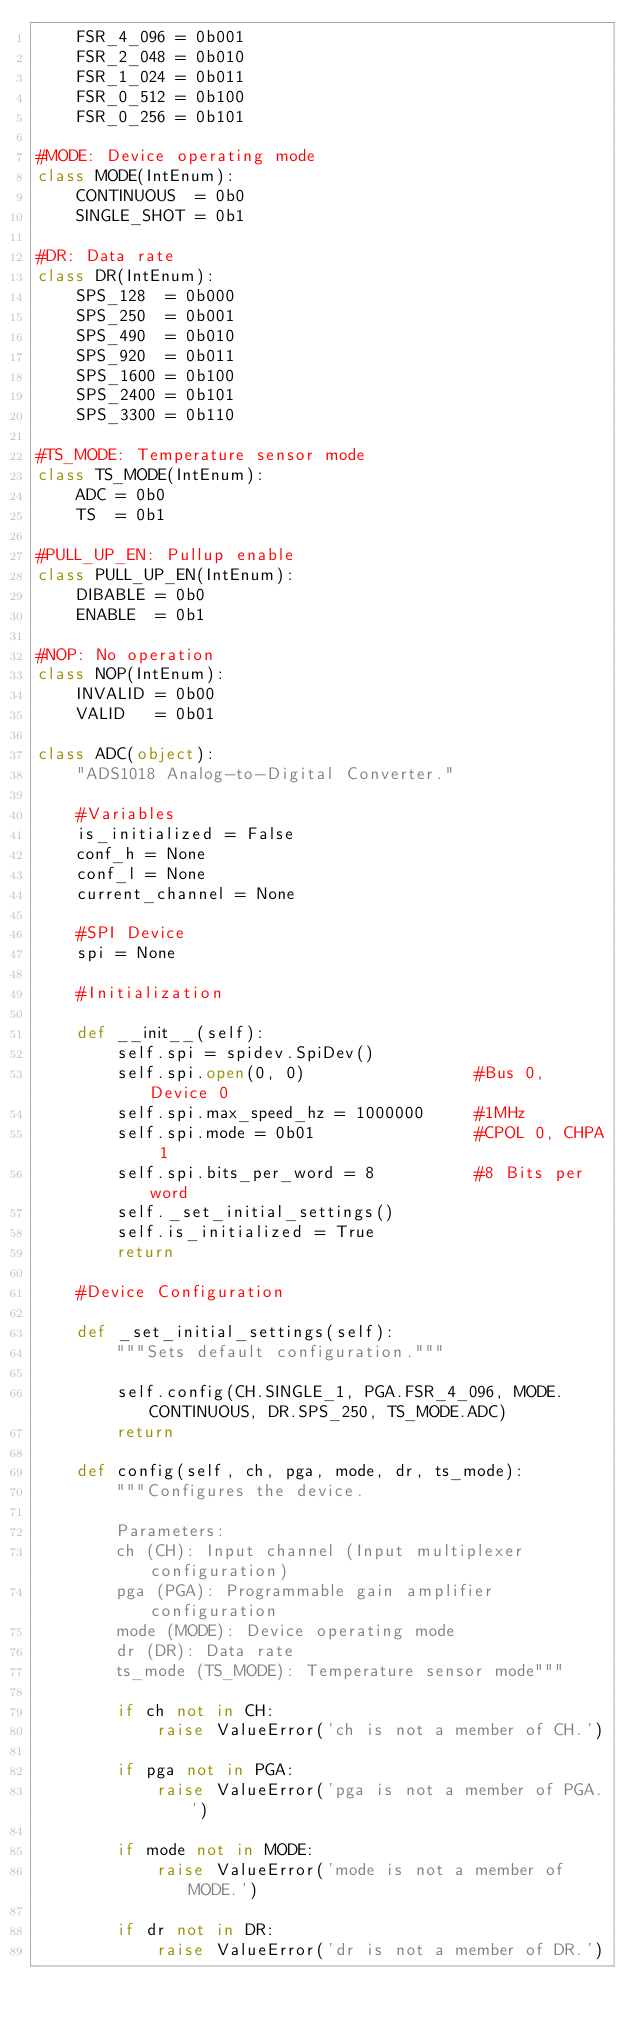<code> <loc_0><loc_0><loc_500><loc_500><_Python_>    FSR_4_096 = 0b001
    FSR_2_048 = 0b010
    FSR_1_024 = 0b011
    FSR_0_512 = 0b100
    FSR_0_256 = 0b101

#MODE: Device operating mode
class MODE(IntEnum):
    CONTINUOUS  = 0b0
    SINGLE_SHOT = 0b1

#DR: Data rate
class DR(IntEnum):
    SPS_128  = 0b000
    SPS_250  = 0b001
    SPS_490  = 0b010
    SPS_920  = 0b011
    SPS_1600 = 0b100
    SPS_2400 = 0b101
    SPS_3300 = 0b110

#TS_MODE: Temperature sensor mode
class TS_MODE(IntEnum):
    ADC = 0b0
    TS  = 0b1

#PULL_UP_EN: Pullup enable
class PULL_UP_EN(IntEnum):
    DIBABLE = 0b0
    ENABLE  = 0b1

#NOP: No operation
class NOP(IntEnum):
    INVALID = 0b00
    VALID   = 0b01

class ADC(object):
    "ADS1018 Analog-to-Digital Converter."

    #Variables
    is_initialized = False
    conf_h = None
    conf_l = None
    current_channel = None

    #SPI Device
    spi = None

    #Initialization

    def __init__(self):
        self.spi = spidev.SpiDev()
        self.spi.open(0, 0)                 #Bus 0, Device 0
        self.spi.max_speed_hz = 1000000     #1MHz
        self.spi.mode = 0b01                #CPOL 0, CHPA 1
        self.spi.bits_per_word = 8          #8 Bits per word
        self._set_initial_settings()
        self.is_initialized = True
        return

    #Device Configuration

    def _set_initial_settings(self):
        """Sets default configuration."""

        self.config(CH.SINGLE_1, PGA.FSR_4_096, MODE.CONTINUOUS, DR.SPS_250, TS_MODE.ADC)
        return

    def config(self, ch, pga, mode, dr, ts_mode):
        """Configures the device.

        Parameters:
        ch (CH): Input channel (Input multiplexer configuration)
        pga (PGA): Programmable gain amplifier configuration
        mode (MODE): Device operating mode
        dr (DR): Data rate
        ts_mode (TS_MODE): Temperature sensor mode"""

        if ch not in CH:
            raise ValueError('ch is not a member of CH.')

        if pga not in PGA:
            raise ValueError('pga is not a member of PGA.')

        if mode not in MODE:
            raise ValueError('mode is not a member of MODE.')

        if dr not in DR:
            raise ValueError('dr is not a member of DR.')
</code> 